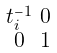Convert formula to latex. <formula><loc_0><loc_0><loc_500><loc_500>\begin{smallmatrix} t ^ { - 1 } _ { i } & 0 \\ 0 & 1 \end{smallmatrix}</formula> 